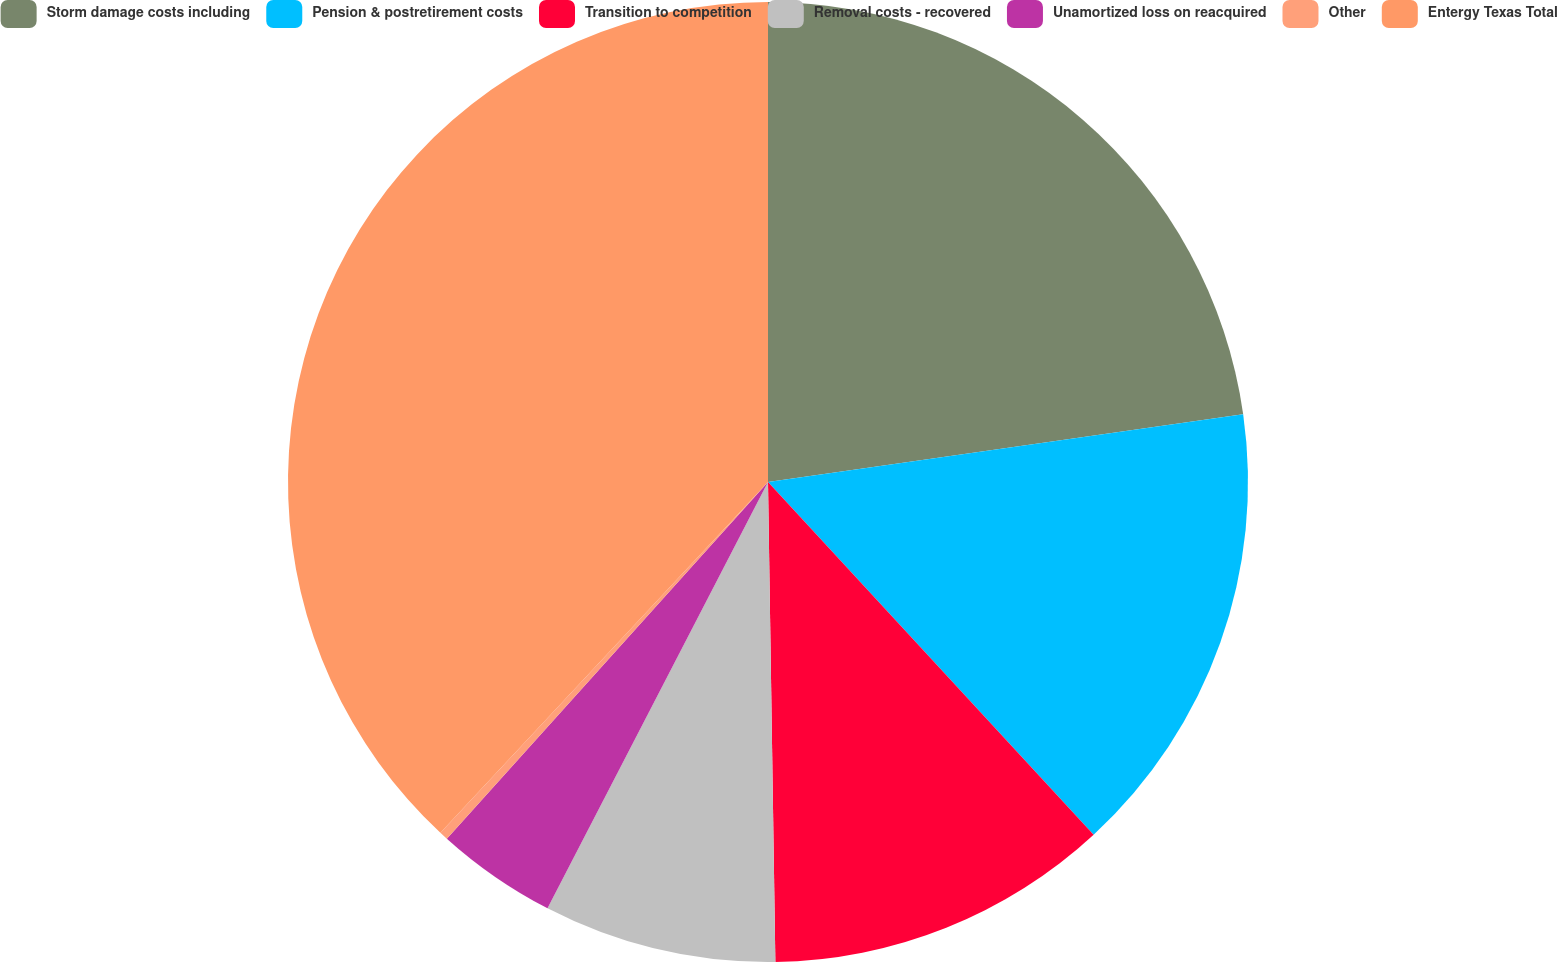Convert chart. <chart><loc_0><loc_0><loc_500><loc_500><pie_chart><fcel>Storm damage costs including<fcel>Pension & postretirement costs<fcel>Transition to competition<fcel>Removal costs - recovered<fcel>Unamortized loss on reacquired<fcel>Other<fcel>Entergy Texas Total<nl><fcel>22.74%<fcel>15.39%<fcel>11.62%<fcel>7.84%<fcel>4.07%<fcel>0.29%<fcel>38.04%<nl></chart> 